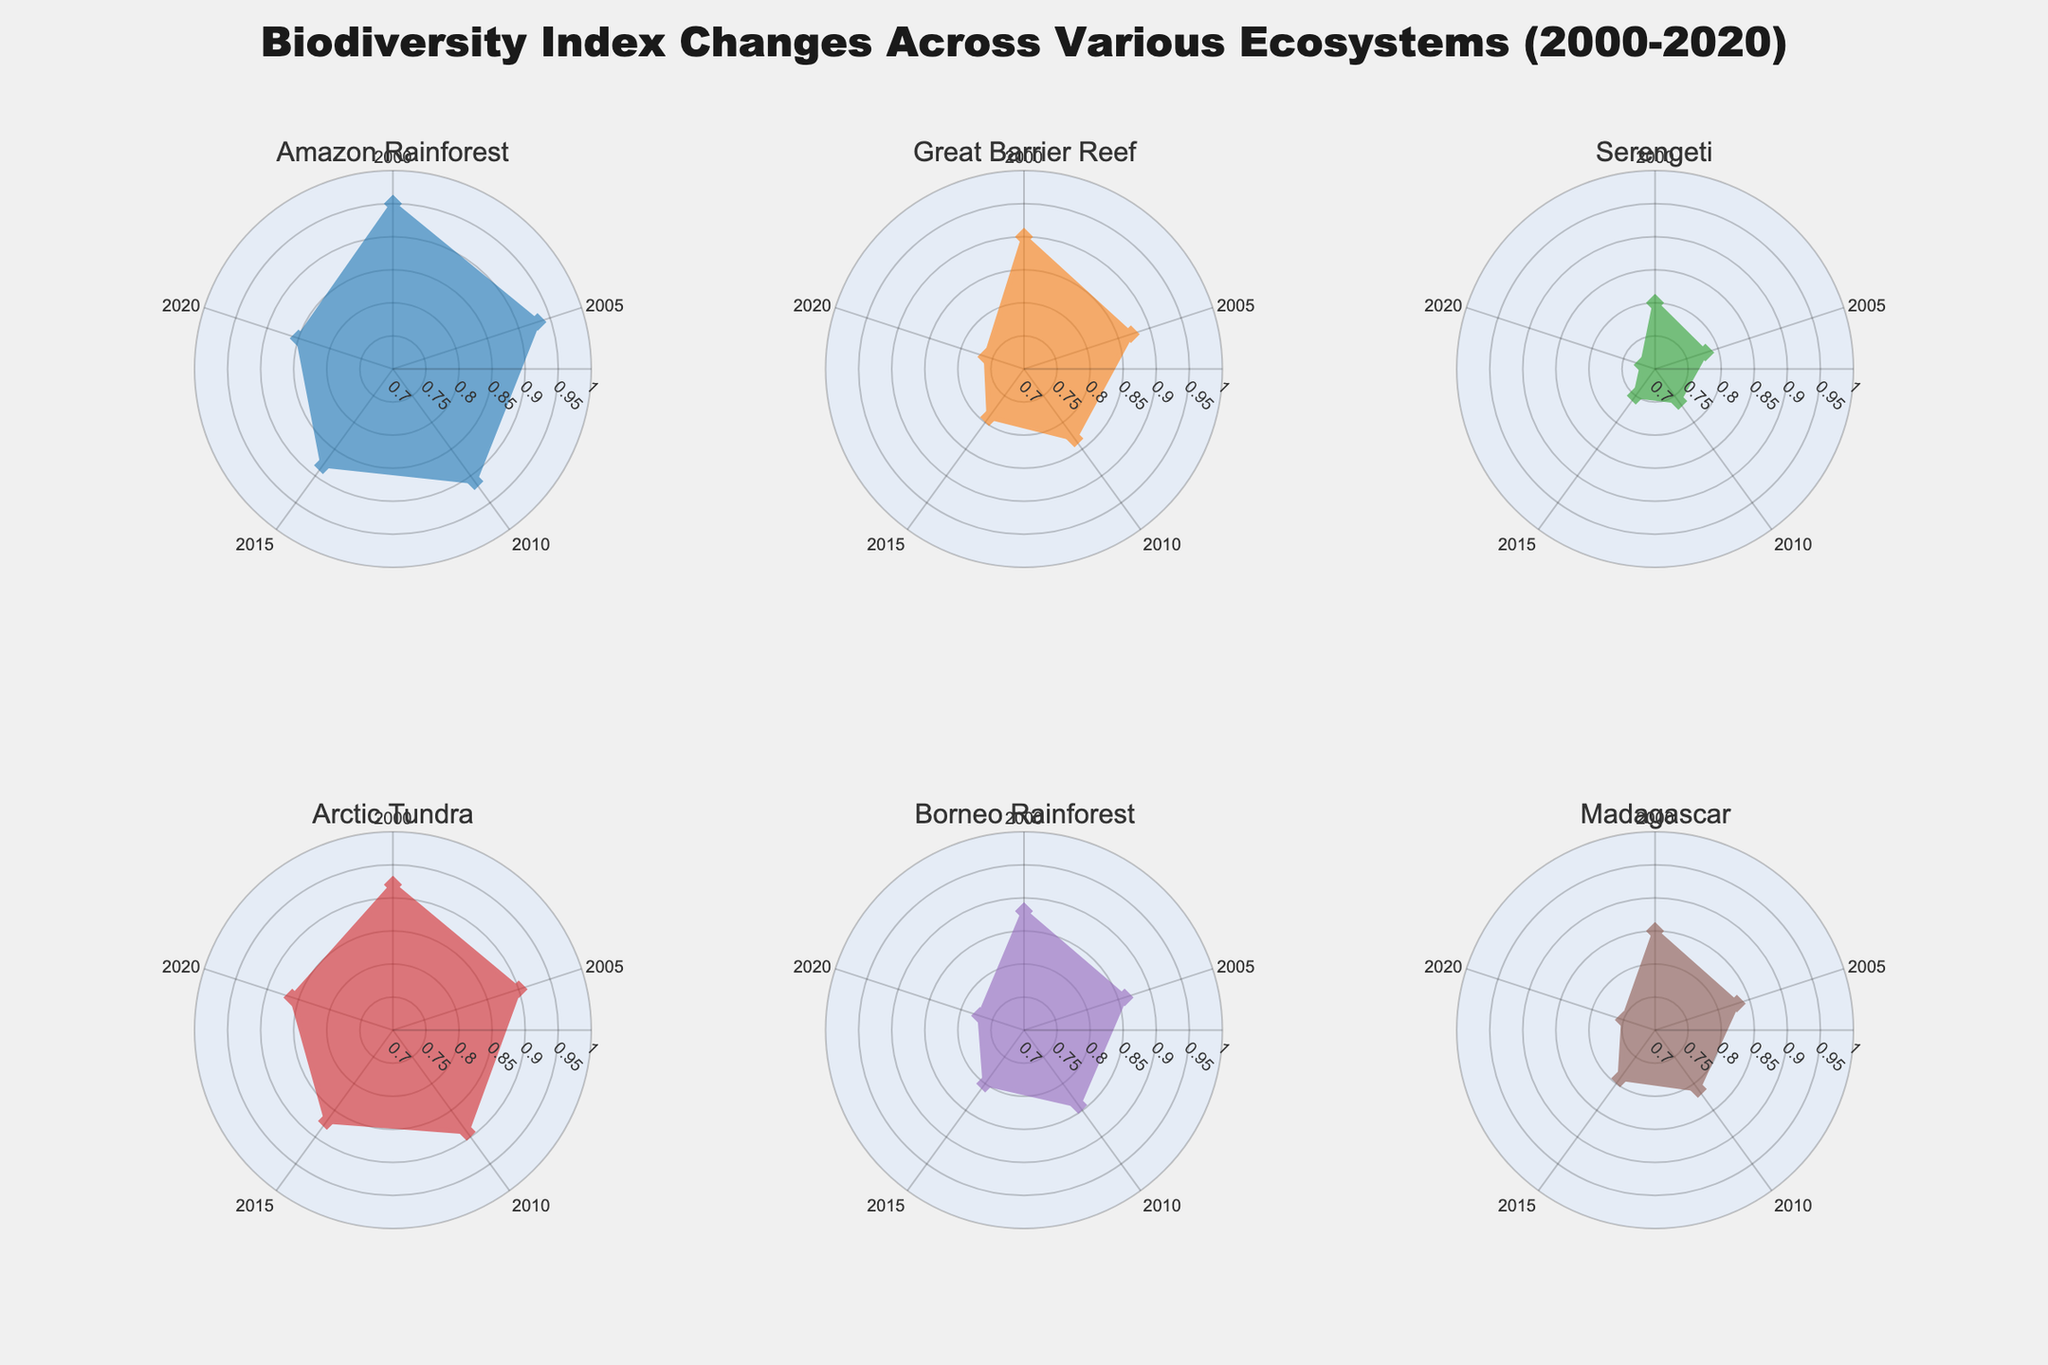What is the range of years shown in the radar charts? The radial axis of each radar chart shows the years from 2000 to 2020 in increments of 5 years: 2000, 2005, 2010, 2015, and 2020.
Answer: 2000-2020 Which ecosystem has the highest Biodiversity Index in the year 2020? All data points in each radar chart on 2020 circle indicate the values. The Arctic Tundra has the highest value at this point.
Answer: Arctic Tundra Compare the Biodiversity Index between the Amazon Rainforest and the Serengeti in 2010. Which one is higher? The data for 2010 on both radar charts shows that the index for the Amazon Rainforest is 0.91 and for the Serengeti is 0.76.
Answer: Amazon Rainforest Which ecosystem has shown the greatest decline in Biodiversity Index from 2000 to 2020? By comparing the difference between 2000 and 2020 for each ecosystem, the Great Barrier Reef has shown the greatest decline from 0.90 to 0.76, a difference of 0.14.
Answer: Great Barrier Reef How does the Biodiversity Index of Madagascar compare to the Borneo Rainforest in 2005? The radar charts show that the values for 2005 for Madagascar and the Borneo Rainforest are 0.83 and 0.86 respectively. Madagascar's Biodiversity Index is lower.
Answer: Madagascar is lower What is the overall trend in Biodiversity Index for each ecosystem? The general trend for all ecosystems shows a decline from 2000 to 2020. Observing the shapes of the polygons and how they shrink towards the center is evident.
Answer: Declining In what year is the Biodiversity Index almost equal for the Arctic Tundra and the Amazon Rainforest? Visual comparison reveals that in the year 2020, the indices are close to each other at 0.86 and 0.85 respectively.
Answer: 2020 Which ecosystem's biodiversity index has the most stable change over the years? Observing the shapes and extent of shrinkage, the Arctic Tundra shows the most stable changes with a slight decline compared to others.
Answer: Arctic Tundra What is the median Biodiversity Index value for the Great Barrier Reef over the years shown? The indices for the Great Barrier Reef are 0.90, 0.87, 0.83, 0.79, and 0.76. Sorting these values as 0.76, 0.79, 0.83, 0.87, 0.90, the median value is the middle one, 0.83.
Answer: 0.83 Which ecosystem saw the smallest decrease in Biodiversity Index by 2010 comparing to the initial values in 2000? By comparing the decrease from 2000 to 2010, the Arctic Tundra decreased from 0.92 to 0.89, a small difference of 0.03, while others have higher differences.
Answer: Arctic Tundra 